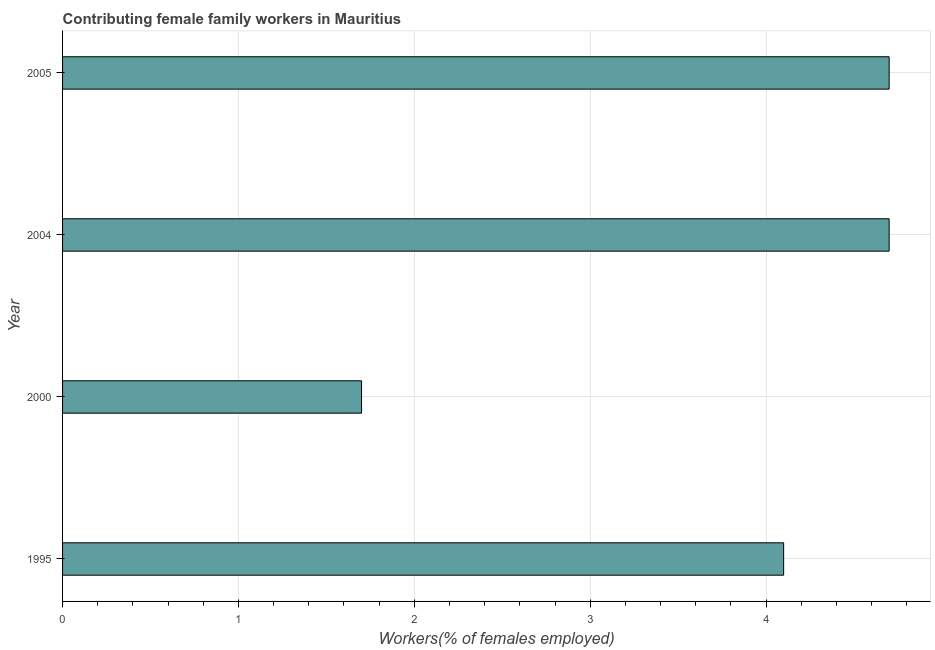Does the graph contain grids?
Your answer should be compact. Yes. What is the title of the graph?
Offer a terse response. Contributing female family workers in Mauritius. What is the label or title of the X-axis?
Your answer should be very brief. Workers(% of females employed). What is the contributing female family workers in 2004?
Provide a short and direct response. 4.7. Across all years, what is the maximum contributing female family workers?
Ensure brevity in your answer.  4.7. Across all years, what is the minimum contributing female family workers?
Provide a succinct answer. 1.7. In which year was the contributing female family workers maximum?
Your answer should be very brief. 2004. In which year was the contributing female family workers minimum?
Keep it short and to the point. 2000. What is the sum of the contributing female family workers?
Ensure brevity in your answer.  15.2. What is the difference between the contributing female family workers in 1995 and 2005?
Offer a very short reply. -0.6. What is the average contributing female family workers per year?
Offer a very short reply. 3.8. What is the median contributing female family workers?
Give a very brief answer. 4.4. What is the ratio of the contributing female family workers in 2000 to that in 2005?
Keep it short and to the point. 0.36. Is the difference between the contributing female family workers in 1995 and 2005 greater than the difference between any two years?
Your answer should be very brief. No. What is the difference between the highest and the second highest contributing female family workers?
Your answer should be very brief. 0. Is the sum of the contributing female family workers in 1995 and 2005 greater than the maximum contributing female family workers across all years?
Offer a terse response. Yes. In how many years, is the contributing female family workers greater than the average contributing female family workers taken over all years?
Ensure brevity in your answer.  3. How many bars are there?
Offer a very short reply. 4. How many years are there in the graph?
Keep it short and to the point. 4. What is the Workers(% of females employed) in 1995?
Offer a very short reply. 4.1. What is the Workers(% of females employed) of 2000?
Give a very brief answer. 1.7. What is the Workers(% of females employed) of 2004?
Provide a short and direct response. 4.7. What is the Workers(% of females employed) of 2005?
Make the answer very short. 4.7. What is the difference between the Workers(% of females employed) in 1995 and 2004?
Your answer should be compact. -0.6. What is the difference between the Workers(% of females employed) in 2000 and 2005?
Make the answer very short. -3. What is the ratio of the Workers(% of females employed) in 1995 to that in 2000?
Provide a short and direct response. 2.41. What is the ratio of the Workers(% of females employed) in 1995 to that in 2004?
Ensure brevity in your answer.  0.87. What is the ratio of the Workers(% of females employed) in 1995 to that in 2005?
Provide a short and direct response. 0.87. What is the ratio of the Workers(% of females employed) in 2000 to that in 2004?
Your response must be concise. 0.36. What is the ratio of the Workers(% of females employed) in 2000 to that in 2005?
Ensure brevity in your answer.  0.36. What is the ratio of the Workers(% of females employed) in 2004 to that in 2005?
Provide a succinct answer. 1. 